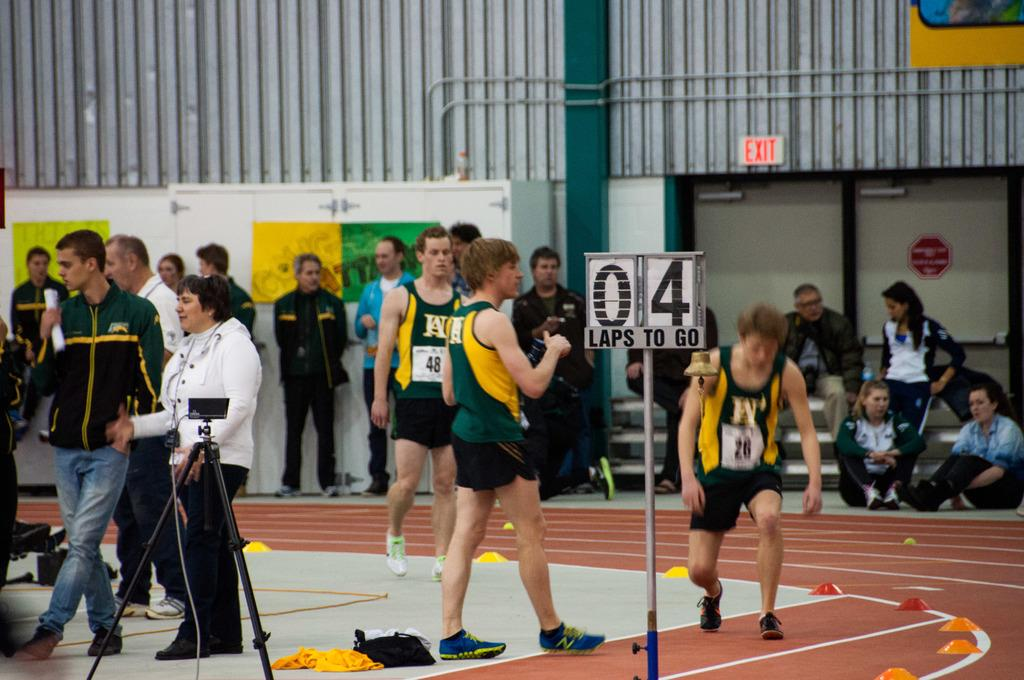Provide a one-sentence caption for the provided image. People racing on a track with a sign that says there are 4 laps to go. 